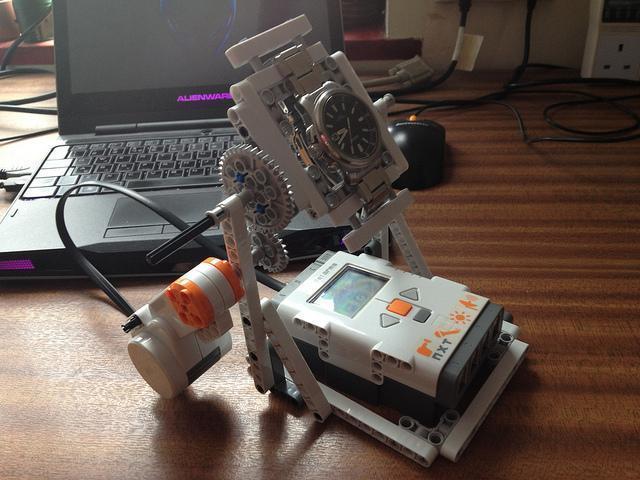How many giraffes are in this picture?
Give a very brief answer. 0. 